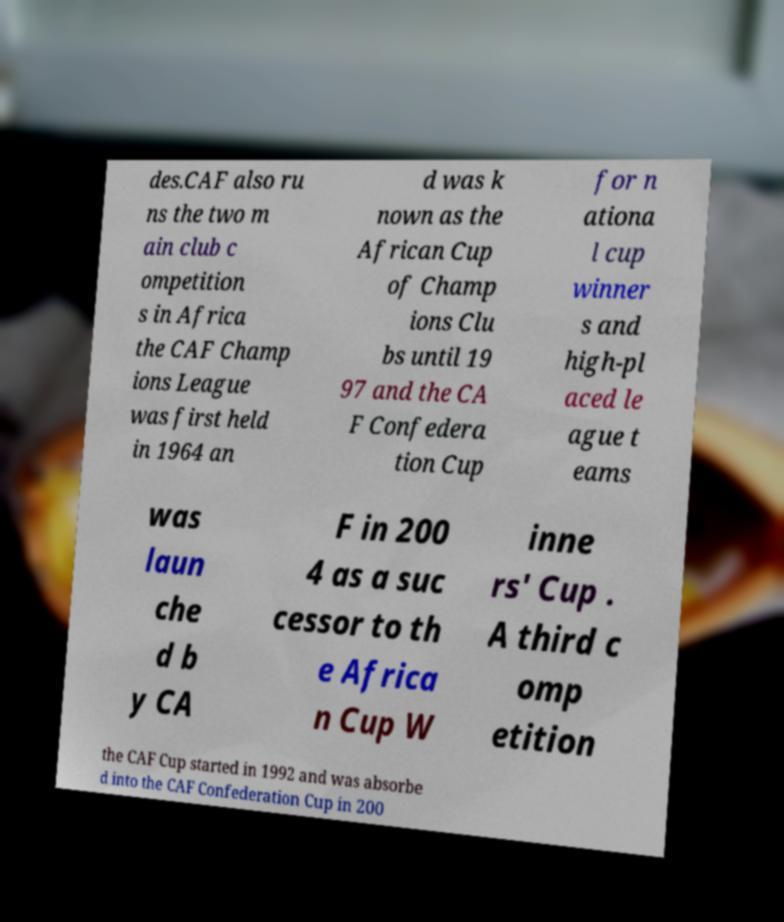For documentation purposes, I need the text within this image transcribed. Could you provide that? des.CAF also ru ns the two m ain club c ompetition s in Africa the CAF Champ ions League was first held in 1964 an d was k nown as the African Cup of Champ ions Clu bs until 19 97 and the CA F Confedera tion Cup for n ationa l cup winner s and high-pl aced le ague t eams was laun che d b y CA F in 200 4 as a suc cessor to th e Africa n Cup W inne rs' Cup . A third c omp etition the CAF Cup started in 1992 and was absorbe d into the CAF Confederation Cup in 200 